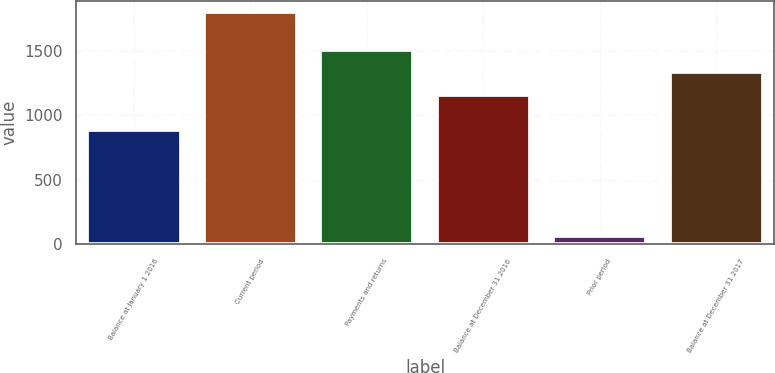<chart> <loc_0><loc_0><loc_500><loc_500><bar_chart><fcel>Balance at January 1 2016<fcel>Current period<fcel>Payments and returns<fcel>Balance at December 31 2016<fcel>Prior period<fcel>Balance at December 31 2017<nl><fcel>890<fcel>1797<fcel>1506.6<fcel>1160<fcel>64<fcel>1333.3<nl></chart> 